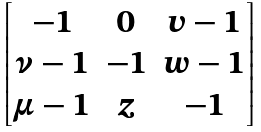Convert formula to latex. <formula><loc_0><loc_0><loc_500><loc_500>\begin{bmatrix} - 1 & 0 & v - 1 \\ \nu - 1 & - 1 & w - 1 \\ \mu - 1 & z & - 1 \end{bmatrix}</formula> 